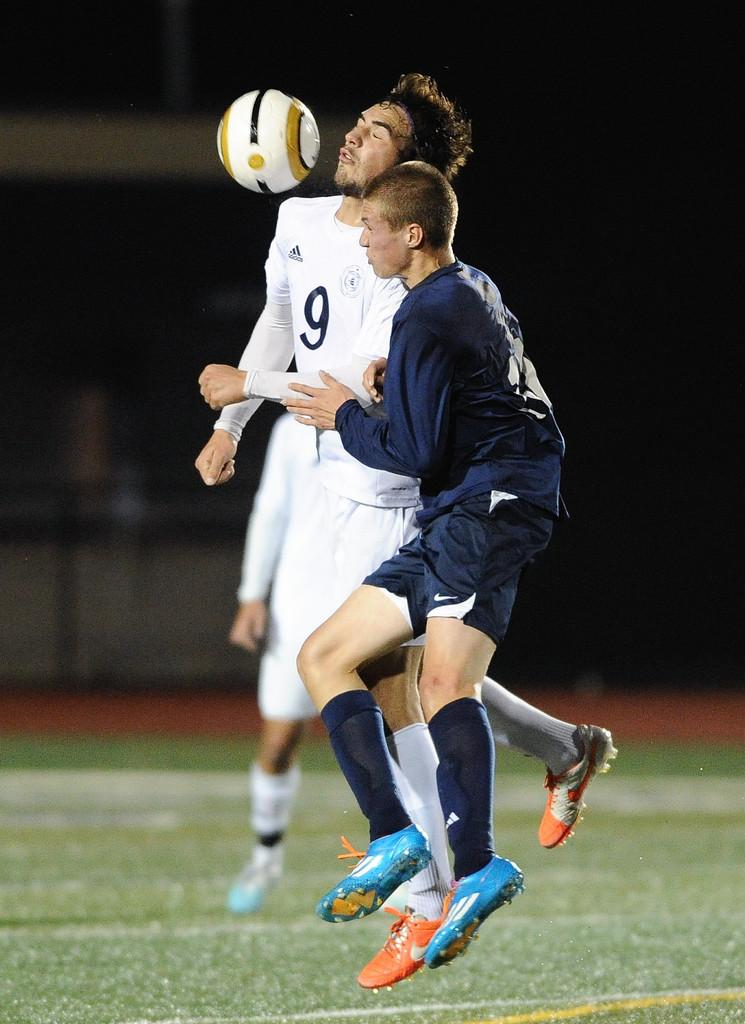<image>
Present a compact description of the photo's key features. Two men are playing soccer on a field and one has the number 9 on his jersey. 